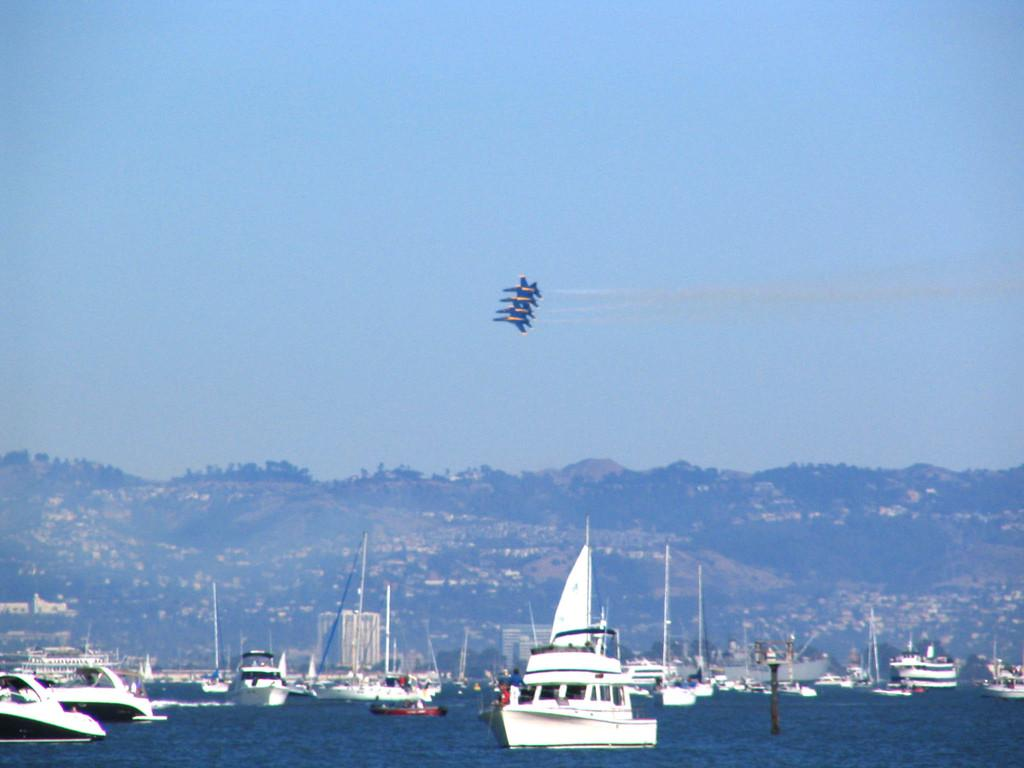What is happening in the water in the image? There are ships sailing on the water in the image. What structures can be seen in the image? There are buildings visible in the image. What type of geographical feature is present in the image? There are hills in the image. What mode of transportation is depicted in the image? There are airways in the image. What part of the natural environment is visible in the image? The sky is visible in the image. Can you describe the taste of the tooth in the image? There is no tooth present in the image, so it is not possible to describe its taste. 